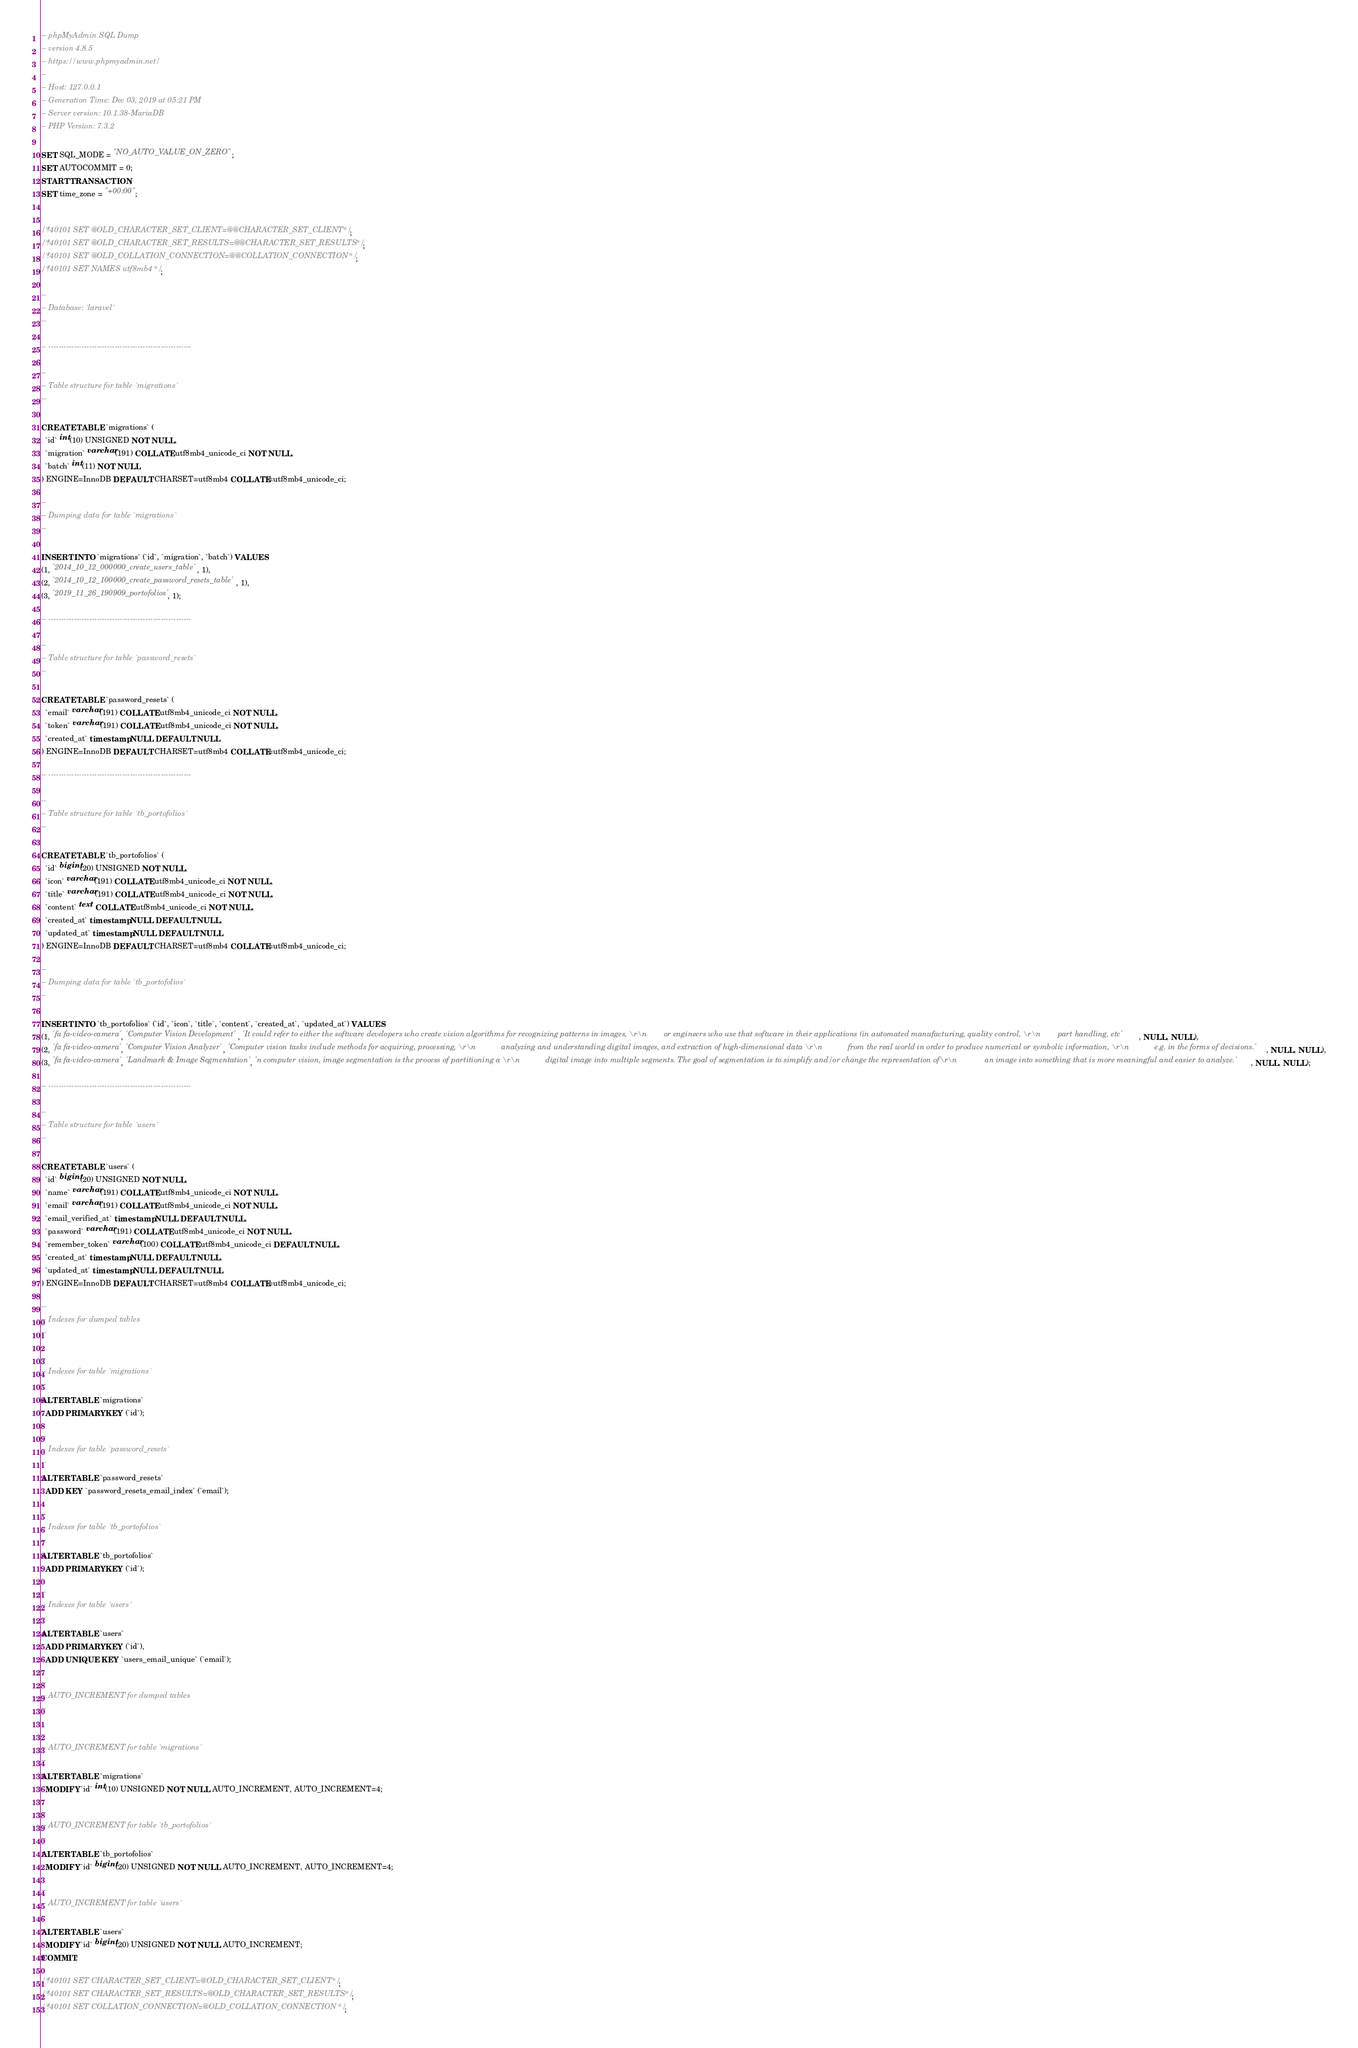<code> <loc_0><loc_0><loc_500><loc_500><_SQL_>-- phpMyAdmin SQL Dump
-- version 4.8.5
-- https://www.phpmyadmin.net/
--
-- Host: 127.0.0.1
-- Generation Time: Dec 03, 2019 at 05:21 PM
-- Server version: 10.1.38-MariaDB
-- PHP Version: 7.3.2

SET SQL_MODE = "NO_AUTO_VALUE_ON_ZERO";
SET AUTOCOMMIT = 0;
START TRANSACTION;
SET time_zone = "+00:00";


/*!40101 SET @OLD_CHARACTER_SET_CLIENT=@@CHARACTER_SET_CLIENT */;
/*!40101 SET @OLD_CHARACTER_SET_RESULTS=@@CHARACTER_SET_RESULTS */;
/*!40101 SET @OLD_COLLATION_CONNECTION=@@COLLATION_CONNECTION */;
/*!40101 SET NAMES utf8mb4 */;

--
-- Database: `laravel`
--

-- --------------------------------------------------------

--
-- Table structure for table `migrations`
--

CREATE TABLE `migrations` (
  `id` int(10) UNSIGNED NOT NULL,
  `migration` varchar(191) COLLATE utf8mb4_unicode_ci NOT NULL,
  `batch` int(11) NOT NULL
) ENGINE=InnoDB DEFAULT CHARSET=utf8mb4 COLLATE=utf8mb4_unicode_ci;

--
-- Dumping data for table `migrations`
--

INSERT INTO `migrations` (`id`, `migration`, `batch`) VALUES
(1, '2014_10_12_000000_create_users_table', 1),
(2, '2014_10_12_100000_create_password_resets_table', 1),
(3, '2019_11_26_190909_portofolios', 1);

-- --------------------------------------------------------

--
-- Table structure for table `password_resets`
--

CREATE TABLE `password_resets` (
  `email` varchar(191) COLLATE utf8mb4_unicode_ci NOT NULL,
  `token` varchar(191) COLLATE utf8mb4_unicode_ci NOT NULL,
  `created_at` timestamp NULL DEFAULT NULL
) ENGINE=InnoDB DEFAULT CHARSET=utf8mb4 COLLATE=utf8mb4_unicode_ci;

-- --------------------------------------------------------

--
-- Table structure for table `tb_portofolios`
--

CREATE TABLE `tb_portofolios` (
  `id` bigint(20) UNSIGNED NOT NULL,
  `icon` varchar(191) COLLATE utf8mb4_unicode_ci NOT NULL,
  `title` varchar(191) COLLATE utf8mb4_unicode_ci NOT NULL,
  `content` text COLLATE utf8mb4_unicode_ci NOT NULL,
  `created_at` timestamp NULL DEFAULT NULL,
  `updated_at` timestamp NULL DEFAULT NULL
) ENGINE=InnoDB DEFAULT CHARSET=utf8mb4 COLLATE=utf8mb4_unicode_ci;

--
-- Dumping data for table `tb_portofolios`
--

INSERT INTO `tb_portofolios` (`id`, `icon`, `title`, `content`, `created_at`, `updated_at`) VALUES
(1, 'fa fa-video-camera', 'Computer Vision Development', 'It could refer to either the software developers who create vision algorithms for recognizing patterns in images, \r\n        or engineers who use that software in their applications (in automated manufacturing, quality control, \r\n        part handling, etc', NULL, NULL),
(2, 'fa fa-video-camera', 'Computer Vision Analyzer', 'Computer vision tasks include methods for acquiring, processing, \r\n            analyzing and understanding digital images, and extraction of high-dimensional data \r\n            from the real world in order to produce numerical or symbolic information, \r\n            e.g. in the forms of decisions.', NULL, NULL),
(3, 'fa fa-video-camera', 'Landmark & Image Segmentation', 'n computer vision, image segmentation is the process of partitioning a \r\n            digital image into multiple segments. The goal of segmentation is to simplify and/or change the representation of\r\n             an image into something that is more meaningful and easier to analyze.', NULL, NULL);

-- --------------------------------------------------------

--
-- Table structure for table `users`
--

CREATE TABLE `users` (
  `id` bigint(20) UNSIGNED NOT NULL,
  `name` varchar(191) COLLATE utf8mb4_unicode_ci NOT NULL,
  `email` varchar(191) COLLATE utf8mb4_unicode_ci NOT NULL,
  `email_verified_at` timestamp NULL DEFAULT NULL,
  `password` varchar(191) COLLATE utf8mb4_unicode_ci NOT NULL,
  `remember_token` varchar(100) COLLATE utf8mb4_unicode_ci DEFAULT NULL,
  `created_at` timestamp NULL DEFAULT NULL,
  `updated_at` timestamp NULL DEFAULT NULL
) ENGINE=InnoDB DEFAULT CHARSET=utf8mb4 COLLATE=utf8mb4_unicode_ci;

--
-- Indexes for dumped tables
--

--
-- Indexes for table `migrations`
--
ALTER TABLE `migrations`
  ADD PRIMARY KEY (`id`);

--
-- Indexes for table `password_resets`
--
ALTER TABLE `password_resets`
  ADD KEY `password_resets_email_index` (`email`);

--
-- Indexes for table `tb_portofolios`
--
ALTER TABLE `tb_portofolios`
  ADD PRIMARY KEY (`id`);

--
-- Indexes for table `users`
--
ALTER TABLE `users`
  ADD PRIMARY KEY (`id`),
  ADD UNIQUE KEY `users_email_unique` (`email`);

--
-- AUTO_INCREMENT for dumped tables
--

--
-- AUTO_INCREMENT for table `migrations`
--
ALTER TABLE `migrations`
  MODIFY `id` int(10) UNSIGNED NOT NULL AUTO_INCREMENT, AUTO_INCREMENT=4;

--
-- AUTO_INCREMENT for table `tb_portofolios`
--
ALTER TABLE `tb_portofolios`
  MODIFY `id` bigint(20) UNSIGNED NOT NULL AUTO_INCREMENT, AUTO_INCREMENT=4;

--
-- AUTO_INCREMENT for table `users`
--
ALTER TABLE `users`
  MODIFY `id` bigint(20) UNSIGNED NOT NULL AUTO_INCREMENT;
COMMIT;

/*!40101 SET CHARACTER_SET_CLIENT=@OLD_CHARACTER_SET_CLIENT */;
/*!40101 SET CHARACTER_SET_RESULTS=@OLD_CHARACTER_SET_RESULTS */;
/*!40101 SET COLLATION_CONNECTION=@OLD_COLLATION_CONNECTION */;
</code> 